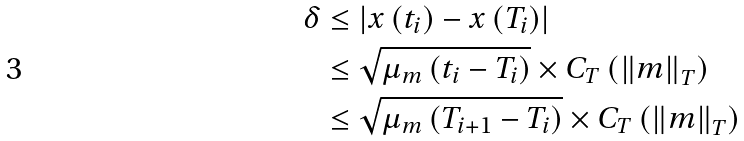Convert formula to latex. <formula><loc_0><loc_0><loc_500><loc_500>\delta & \leq \left | x \left ( t _ { i } \right ) - x \left ( T _ { i } \right ) \right | \\ & \leq \sqrt { \mu _ { m } \left ( t _ { i } - T _ { i } \right ) } \times C _ { T } \left ( \left \| m \right \| _ { T } \right ) \\ & \leq \sqrt { \mu _ { m } \left ( T _ { i + 1 } - T _ { i } \right ) } \times C _ { T } \left ( \left \| m \right \| _ { T } \right )</formula> 